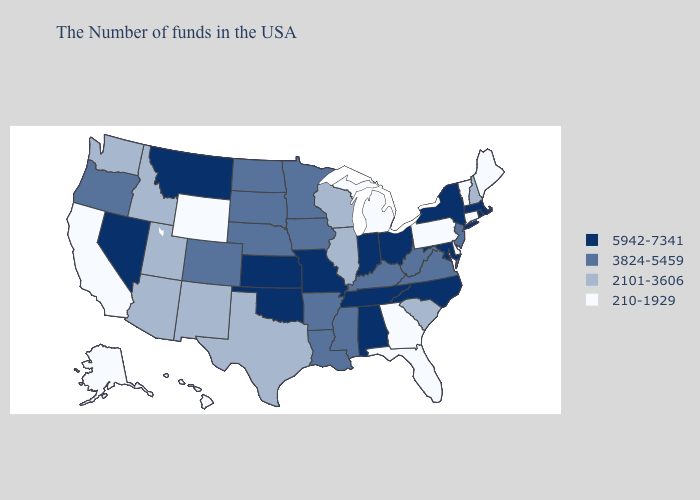Is the legend a continuous bar?
Write a very short answer. No. Name the states that have a value in the range 3824-5459?
Answer briefly. New Jersey, Virginia, West Virginia, Kentucky, Mississippi, Louisiana, Arkansas, Minnesota, Iowa, Nebraska, South Dakota, North Dakota, Colorado, Oregon. What is the value of South Dakota?
Answer briefly. 3824-5459. Does Kansas have a lower value than Mississippi?
Short answer required. No. What is the value of Massachusetts?
Quick response, please. 5942-7341. What is the value of Washington?
Quick response, please. 2101-3606. What is the value of Utah?
Keep it brief. 2101-3606. Among the states that border Ohio , which have the highest value?
Give a very brief answer. Indiana. Name the states that have a value in the range 3824-5459?
Keep it brief. New Jersey, Virginia, West Virginia, Kentucky, Mississippi, Louisiana, Arkansas, Minnesota, Iowa, Nebraska, South Dakota, North Dakota, Colorado, Oregon. Does the first symbol in the legend represent the smallest category?
Write a very short answer. No. Which states have the lowest value in the South?
Short answer required. Delaware, Florida, Georgia. Name the states that have a value in the range 3824-5459?
Give a very brief answer. New Jersey, Virginia, West Virginia, Kentucky, Mississippi, Louisiana, Arkansas, Minnesota, Iowa, Nebraska, South Dakota, North Dakota, Colorado, Oregon. What is the value of Iowa?
Keep it brief. 3824-5459. Which states hav the highest value in the Northeast?
Give a very brief answer. Massachusetts, Rhode Island, New York. Does Maine have the same value as South Carolina?
Write a very short answer. No. 